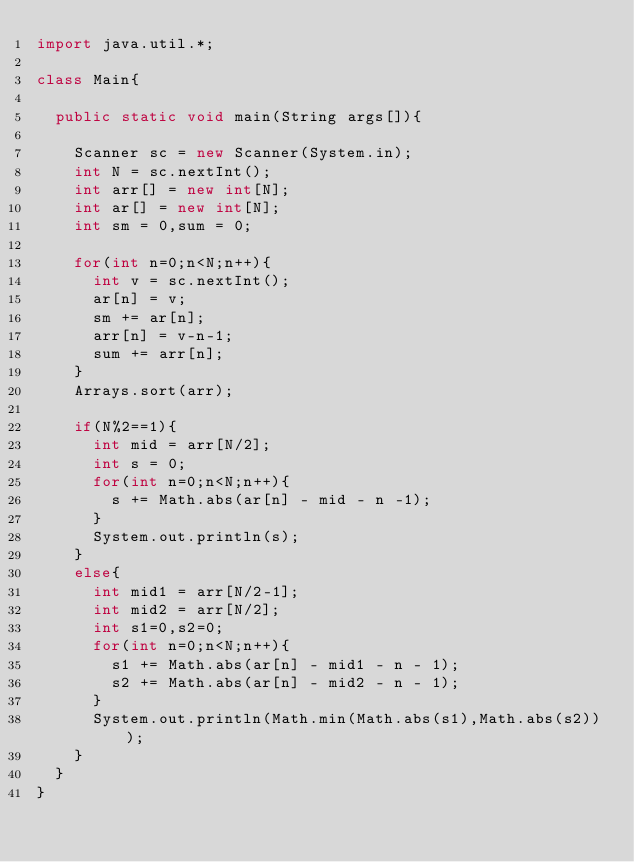Convert code to text. <code><loc_0><loc_0><loc_500><loc_500><_Java_>import java.util.*;

class Main{
	
	public static void main(String args[]){

		Scanner sc = new Scanner(System.in);
		int N = sc.nextInt();
		int arr[] = new int[N];
		int ar[] = new int[N];
		int sm = 0,sum = 0;

		for(int n=0;n<N;n++){
			int v = sc.nextInt();
			ar[n] = v;
			sm += ar[n];
			arr[n] = v-n-1;
			sum += arr[n];
		}
		Arrays.sort(arr);

		if(N%2==1){
			int mid = arr[N/2];
			int s = 0;
			for(int n=0;n<N;n++){
				s += Math.abs(ar[n] - mid - n -1);
			}
			System.out.println(s);
		}
		else{
			int mid1 = arr[N/2-1];
			int mid2 = arr[N/2];
			int s1=0,s2=0;
			for(int n=0;n<N;n++){
				s1 += Math.abs(ar[n] - mid1 - n - 1);
				s2 += Math.abs(ar[n] - mid2 - n - 1);
			}
			System.out.println(Math.min(Math.abs(s1),Math.abs(s2)));
		}
	}
}</code> 